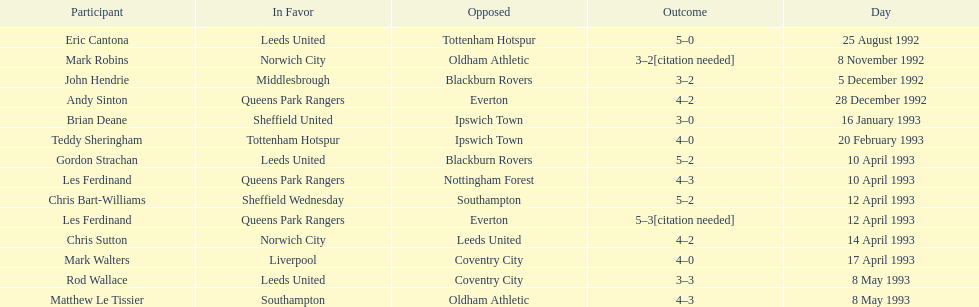Name the players for tottenham hotspur. Teddy Sheringham. 